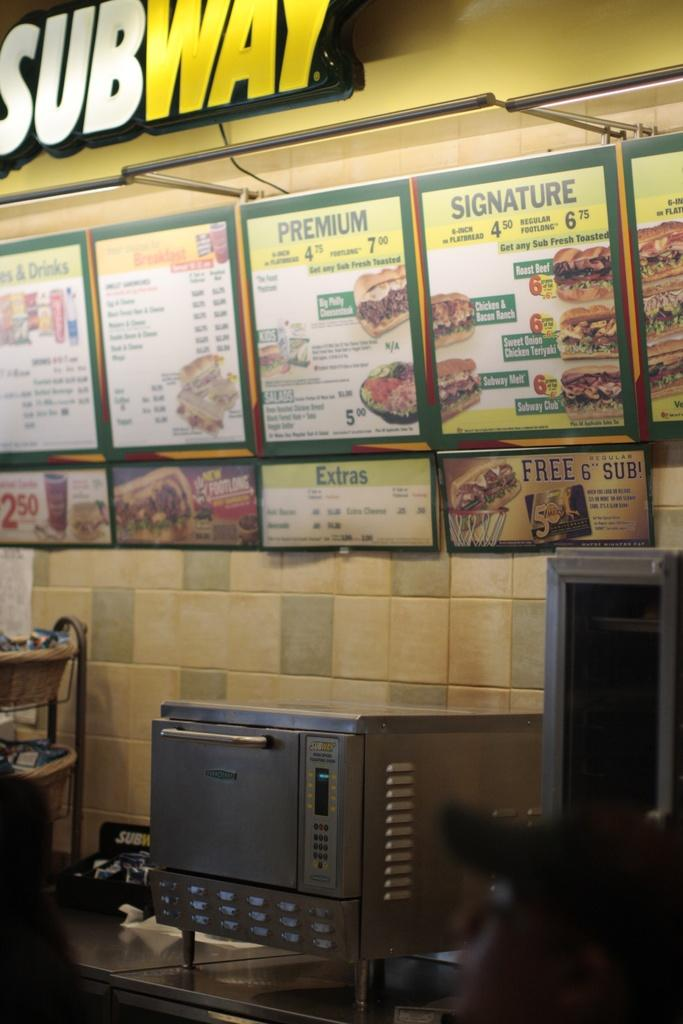<image>
Relay a brief, clear account of the picture shown. A sign that says SUBWAY with a menu board underneath it that says Premium and Signature. 